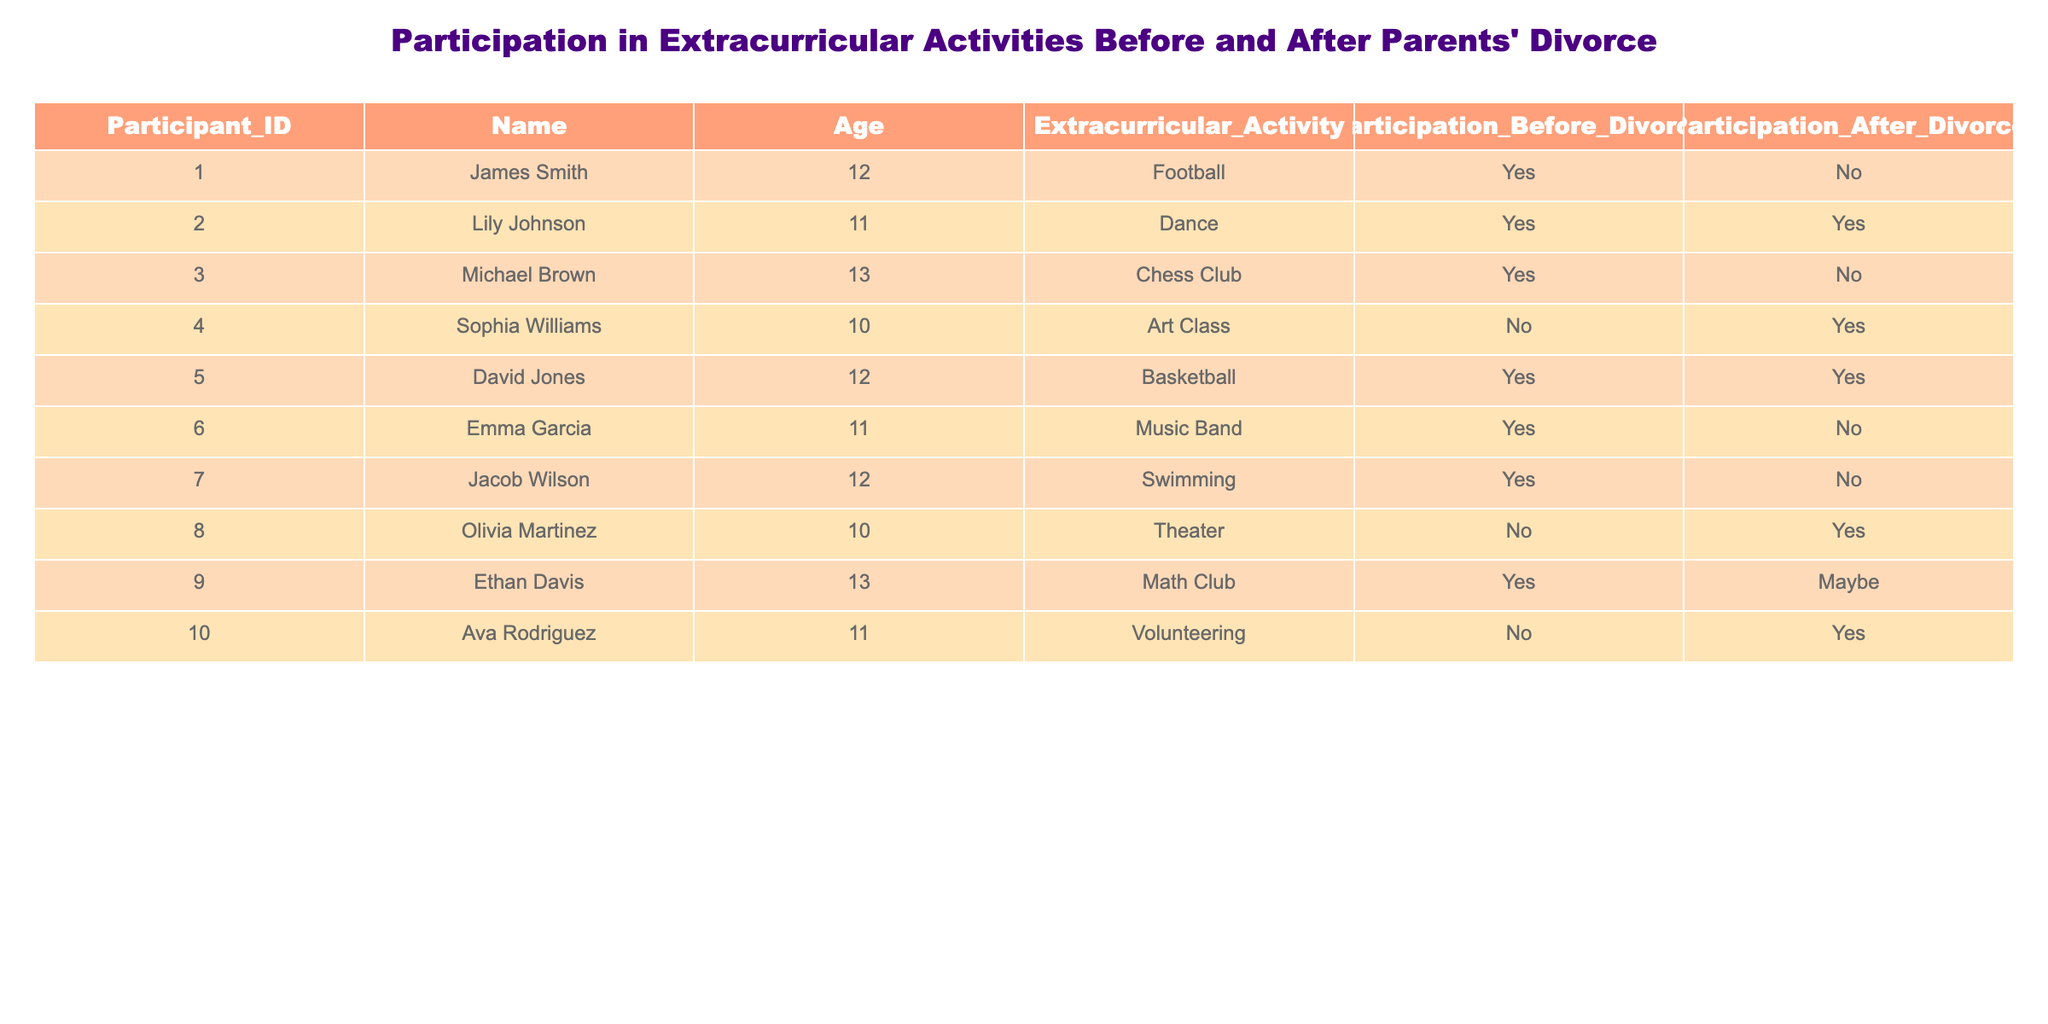What was the extracurricular activity of James Smith? To find the extracurricular activity of James Smith, I check the table for the row where the Name column matches "James Smith." I see that the Extracurricular Activity column states "Football."
Answer: Football How many participants had their participation in extracurricular activities change from before to after the divorce? I look through the Participation Before Divorce and Participation After Divorce columns. I find that James Smith, Michael Brown, Emma Garcia, and Jacob Wilson stopped participating, while Sophia Williams and Olivia Martinez started after the divorce. This totals six participants who had a change in their participation.
Answer: 6 What extracurricular activities did participants continue after the divorce? To answer this, I check the Participation After Divorce column for "Yes" values and note the corresponding extracurricular activities. Those are Dance (Lily Johnson), Basketball (David Jones), and Volunteering (Ava Rodriguez).
Answer: Dance, Basketball, Volunteering Are there any participants that did not participate in any extracurricular activities before the divorce but started after? I check the Participation Before Divorce column for "No" and find Sophia Williams (Art Class) and Olivia Martinez (Theater) who both had "Yes" in Participation After Divorce, indicating they started after their parents' divorce.
Answer: Yes What is the percentage of participants who did not participate in extracurricular activities after the divorce? To find this, I first count the total number of participants (10), then count how many did not participate after the divorce (4: James Smith, Michael Brown, Emma Garcia, Jacob Wilson). The percentage calculation is (4/10) * 100 = 40%.
Answer: 40% Which participant had an uncertain status for participation after the divorce? I look for the row where the Participation After Divorce column has the value "Maybe." I see that this applies to Ethan Davis.
Answer: Ethan Davis What was the most common extracurricular activity participated in before the divorce? I tally the extracurricular activities listed in the table before the divorce. The activities were: Football (1), Dance (1), Chess Club (1), Art Class (0), Basketball (1), Music Band (1), Swimming (1), Theater (0), Math Club (1), and Volunteering (0). The most common activities before the divorce are Football, Dance, Basketball, Music Band, Swimming, and Math Club (all with 1). Since there's a tie, I mention more than one.
Answer: Football, Dance, Basketball, Music Band, Swimming, Math Club How many participants are older than 11 and did not participate after the divorce? I identify the participants older than 11: Michael Brown (13), Ethan Davis (13), and Jacob Wilson (12). From this group, I check their participation status after the divorce. Michael Brown and Jacob Wilson did not participate after the divorce. Hence, there are 2 such participants.
Answer: 2 